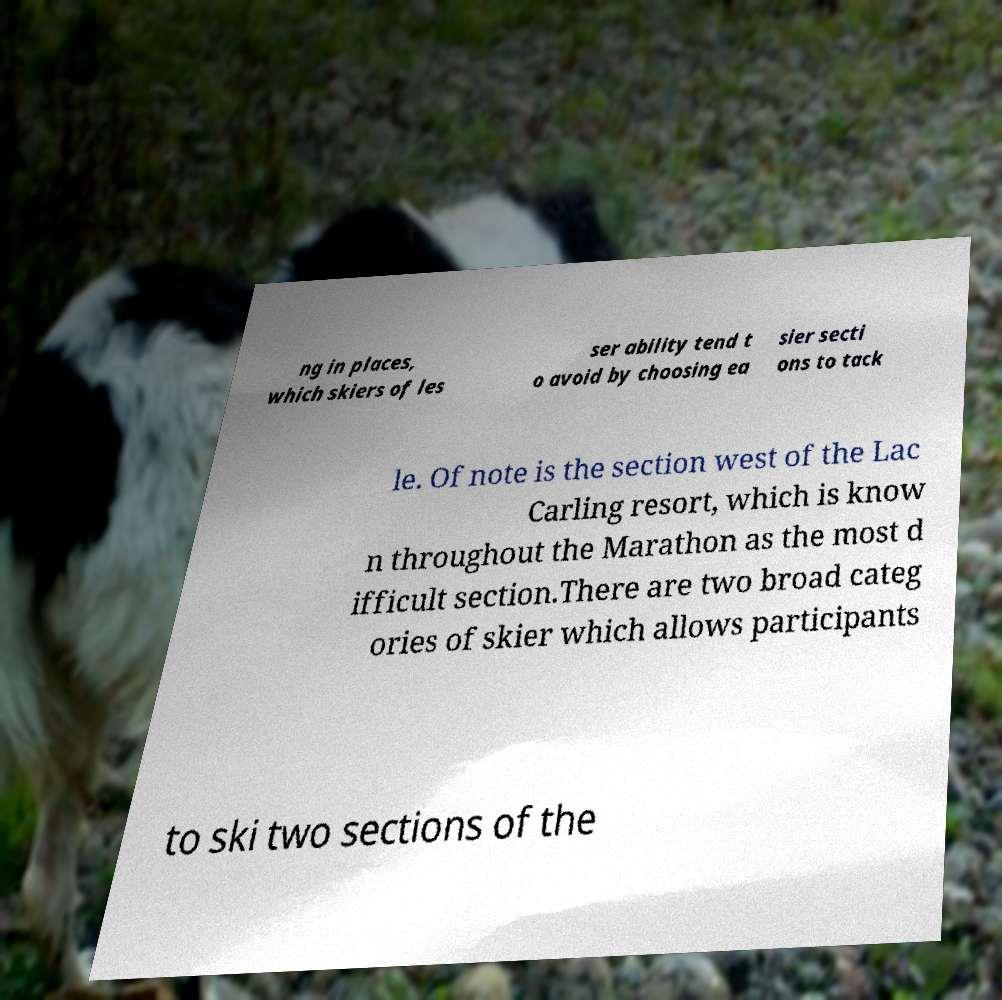I need the written content from this picture converted into text. Can you do that? ng in places, which skiers of les ser ability tend t o avoid by choosing ea sier secti ons to tack le. Of note is the section west of the Lac Carling resort, which is know n throughout the Marathon as the most d ifficult section.There are two broad categ ories of skier which allows participants to ski two sections of the 